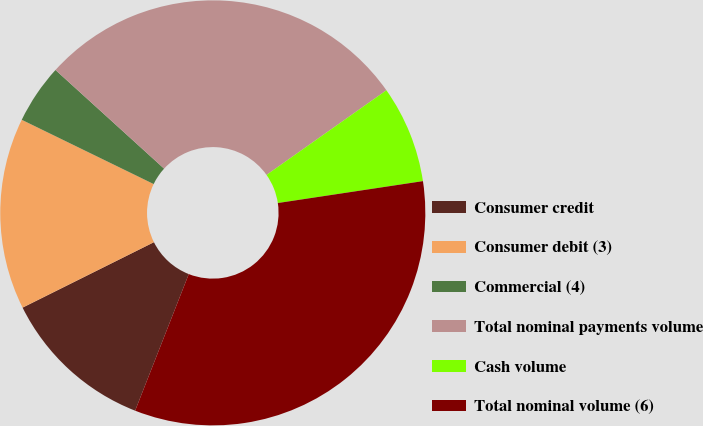Convert chart. <chart><loc_0><loc_0><loc_500><loc_500><pie_chart><fcel>Consumer credit<fcel>Consumer debit (3)<fcel>Commercial (4)<fcel>Total nominal payments volume<fcel>Cash volume<fcel>Total nominal volume (6)<nl><fcel>11.69%<fcel>14.57%<fcel>4.52%<fcel>28.48%<fcel>7.4%<fcel>33.34%<nl></chart> 